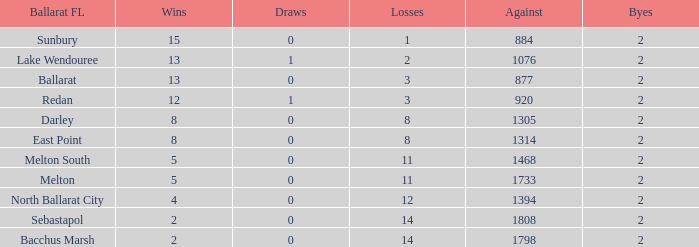How many losses are there in a ballarat fl of melton south, with a confrontation exceeding 1468? 0.0. 